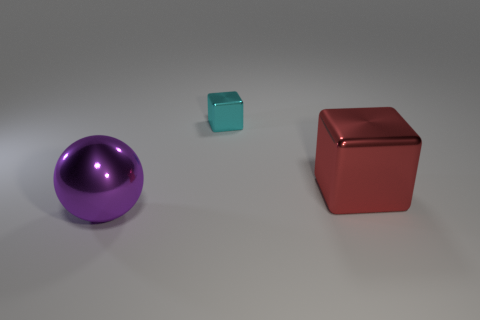Subtract all cyan blocks. How many blocks are left? 1 Add 2 blocks. How many objects exist? 5 Subtract all metallic things. Subtract all small green metallic cubes. How many objects are left? 0 Add 3 metal balls. How many metal balls are left? 4 Add 2 big purple shiny cylinders. How many big purple shiny cylinders exist? 2 Subtract 0 cyan cylinders. How many objects are left? 3 Subtract all blocks. How many objects are left? 1 Subtract all gray cubes. Subtract all blue cylinders. How many cubes are left? 2 Subtract all red cylinders. How many purple cubes are left? 0 